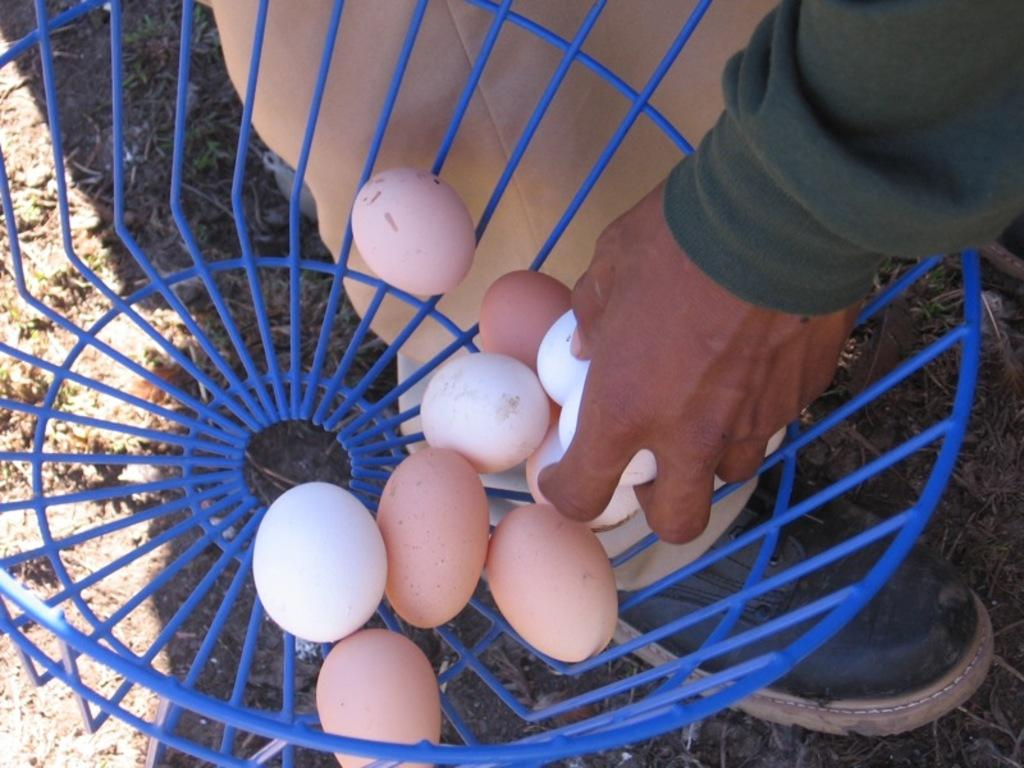What is the person holding in the image? The person is holding an egg in the image. What else can be seen related to eggs in the image? There is a mesh container with eggs in the image. What type of toys can be seen in the image? There are no toys present in the image. How does the person's sense of smell contribute to the image? The person's sense of smell is not depicted or mentioned in the image, so it cannot be determined how it contributes. 